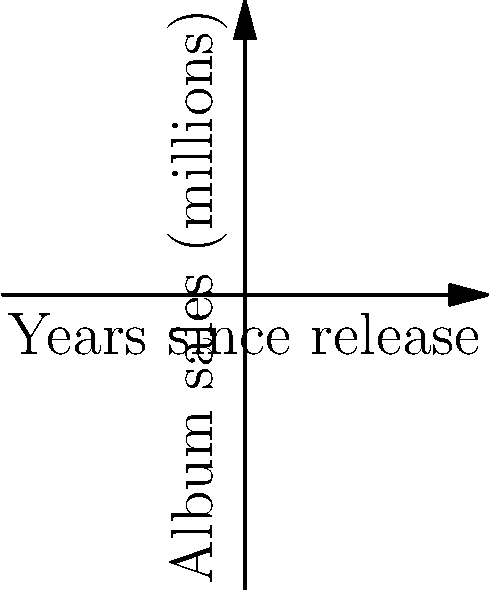As a radio DJ, you're analyzing the sales performance of two popular Cantopop albums. Album A sold 1.5 million copies upon release, while Album B sold 3.8 million copies two years after its release. Using the graph, calculate the slope of the line connecting these two data points. What does this slope represent in the context of album sales? To calculate the slope of the line connecting the two data points, we'll use the slope formula:

$$ \text{slope} = \frac{\text{change in y}}{\text{change in x}} = \frac{y_2 - y_1}{x_2 - x_1} $$

Given:
- Album A: $(x_1, y_1) = (0, 1.5)$
- Album B: $(x_2, y_2) = (2, 3.8)$

Step 1: Calculate the change in y (album sales)
$\Delta y = y_2 - y_1 = 3.8 - 1.5 = 2.3$ million

Step 2: Calculate the change in x (years)
$\Delta x = x_2 - x_1 = 2 - 0 = 2$ years

Step 3: Apply the slope formula
$$ \text{slope} = \frac{2.3}{2} = 1.15 $$

The slope of 1.15 represents the average increase in album sales per year between the two data points. In the context of album sales, this means that on average, the sales increased by 1.15 million copies per year over the two-year period.
Answer: 1.15 million copies per year 